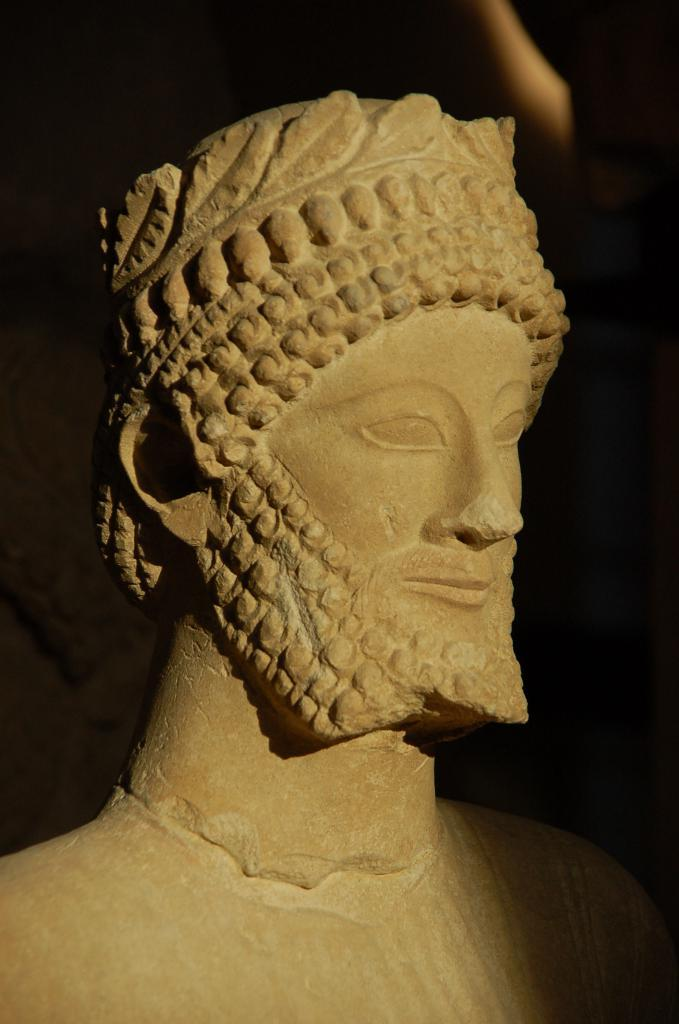What is the main subject of the image? There is a statue of a person in the image. What can be seen in the background of the image? The background of the image is black. How many flowers are surrounding the statue in the image? There are no flowers present in the image; it only features a statue of a person with a black background. 